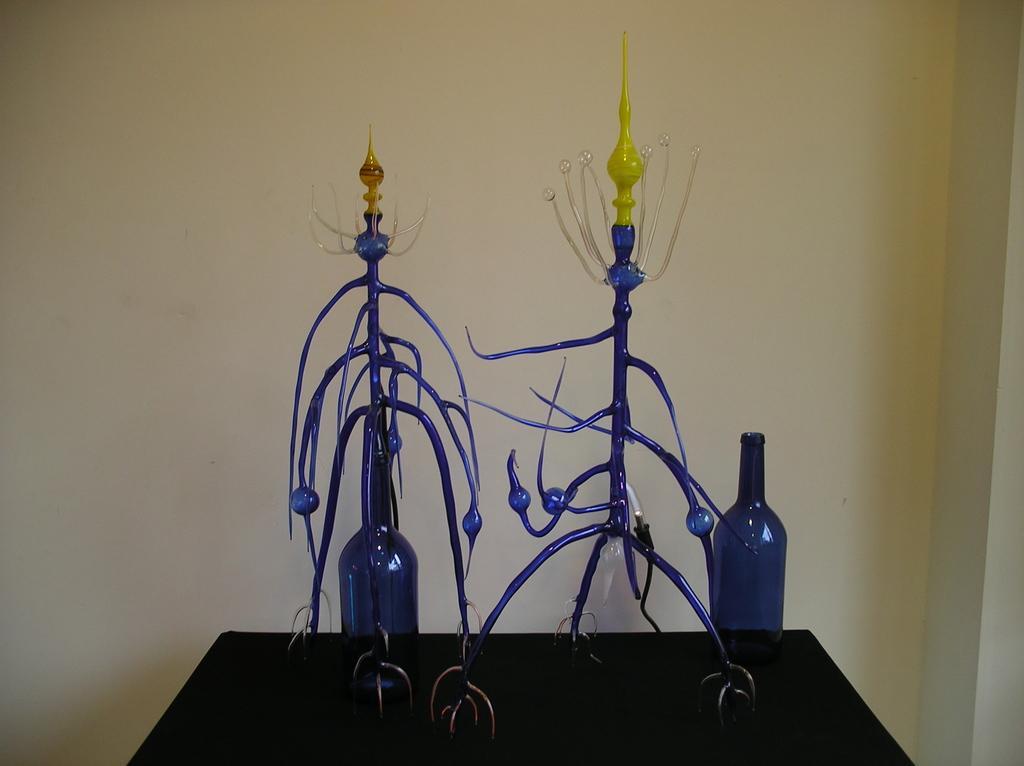In one or two sentences, can you explain what this image depicts? In this image i can see a table and 2 glass bottles on it, and in the background i can see a wall. 